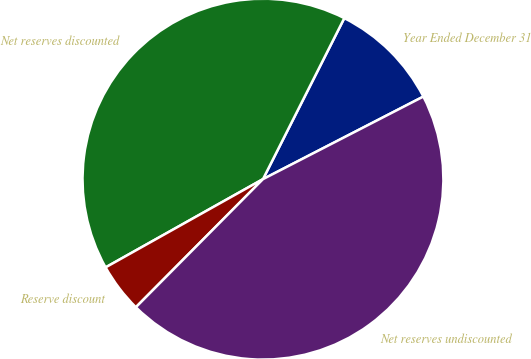Convert chart. <chart><loc_0><loc_0><loc_500><loc_500><pie_chart><fcel>Year Ended December 31<fcel>Net reserves discounted<fcel>Reserve discount<fcel>Net reserves undiscounted<nl><fcel>9.99%<fcel>40.58%<fcel>4.43%<fcel>45.01%<nl></chart> 